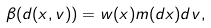Convert formula to latex. <formula><loc_0><loc_0><loc_500><loc_500>\beta ( d ( x , v ) ) = w ( x ) m ( d x ) d v ,</formula> 